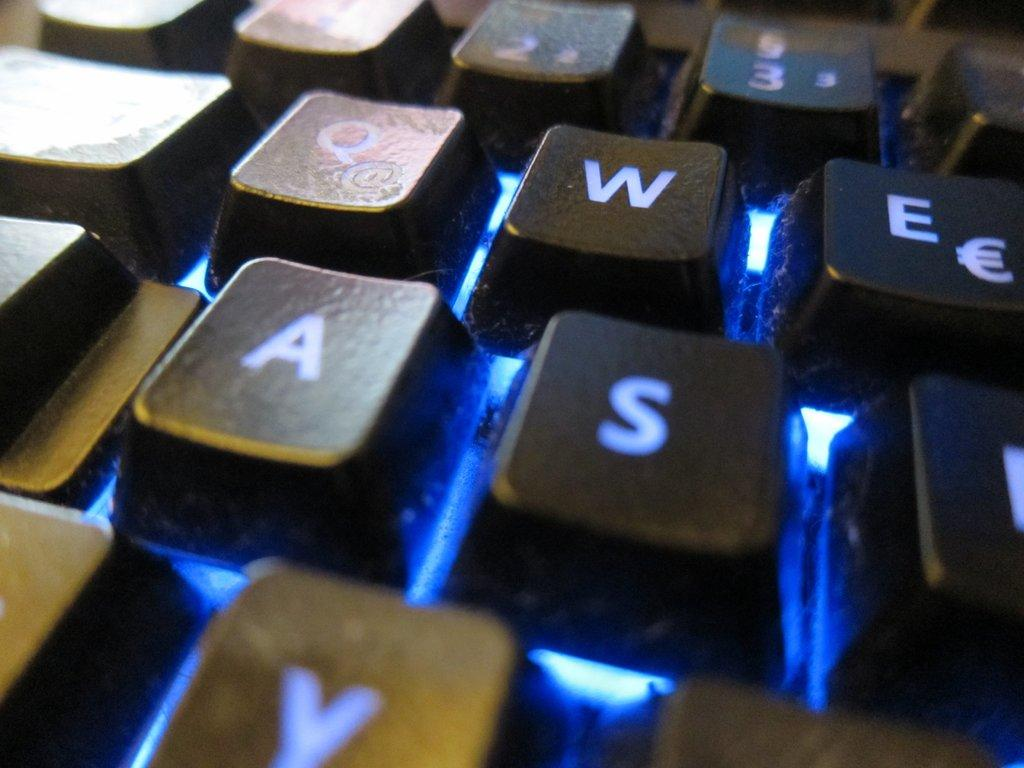What color are the keyboard keys in the image? The keyboard keys in the image are black. Can you describe any other visual elements in the image? Yes, there is a blue color light visible in the image. How many quinces are being transported in the image? There are no quinces or any form of transportation present in the image. 